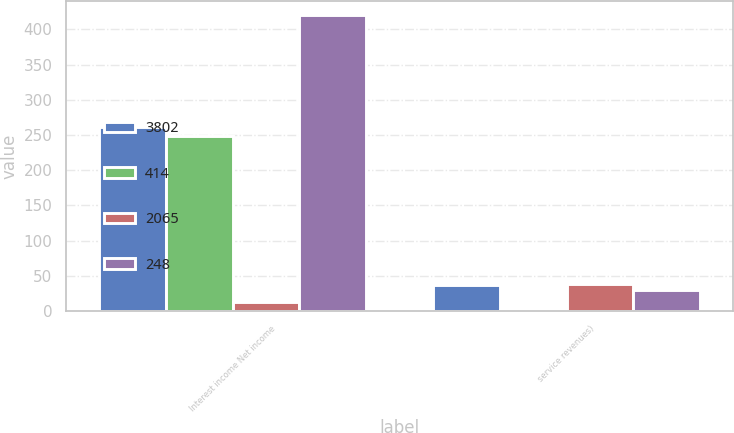Convert chart to OTSL. <chart><loc_0><loc_0><loc_500><loc_500><stacked_bar_chart><ecel><fcel>Interest income Net income<fcel>service revenues)<nl><fcel>3802<fcel>261<fcel>37<nl><fcel>414<fcel>248<fcel>1<nl><fcel>2065<fcel>13<fcel>38<nl><fcel>248<fcel>420<fcel>30<nl></chart> 